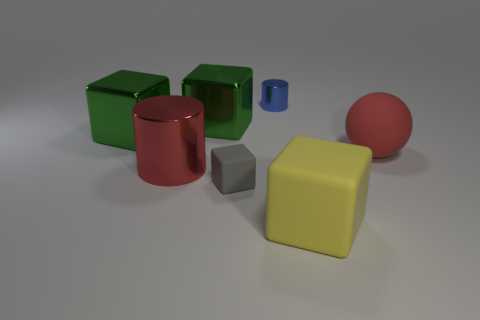Does the gray cube have the same size as the metal cylinder that is to the left of the tiny gray block?
Make the answer very short. No. The large red thing that is on the left side of the yellow thing has what shape?
Offer a very short reply. Cylinder. Are there any other things that are the same shape as the red matte object?
Your answer should be compact. No. Is there a small brown cylinder?
Your answer should be compact. No. Does the cylinder that is left of the tiny metal cylinder have the same size as the matte cube that is behind the large yellow matte object?
Offer a very short reply. No. What material is the object that is in front of the big red shiny thing and left of the yellow cube?
Offer a very short reply. Rubber. There is a tiny gray rubber object; how many red rubber objects are behind it?
Ensure brevity in your answer.  1. What color is the other block that is made of the same material as the gray cube?
Give a very brief answer. Yellow. Is the gray thing the same shape as the small blue metal thing?
Keep it short and to the point. No. What number of things are left of the big matte block and behind the tiny matte cube?
Provide a short and direct response. 4. 